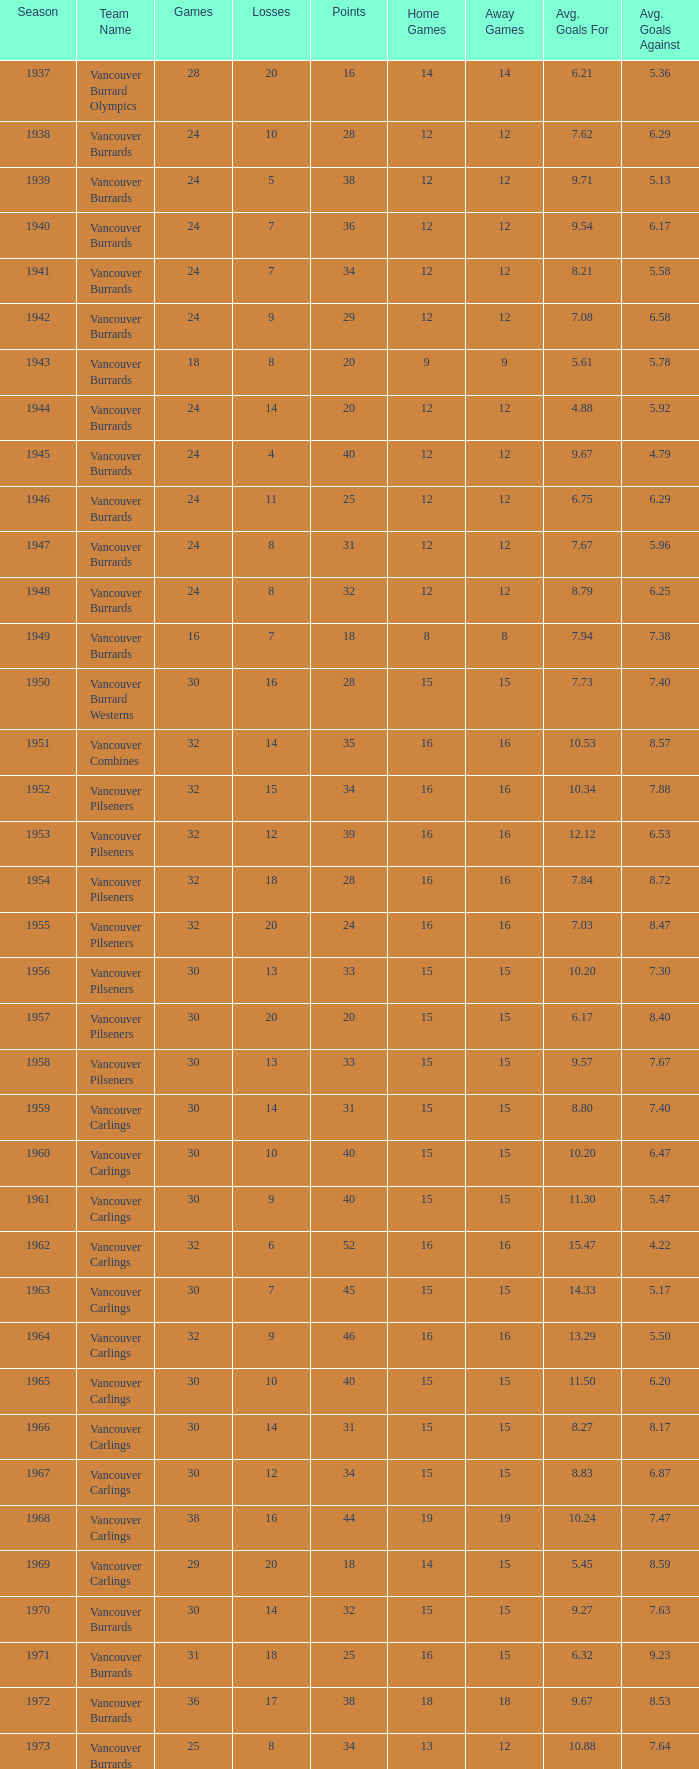What's the sum of points for the 1963 season when there are more than 30 games? None. Could you parse the entire table as a dict? {'header': ['Season', 'Team Name', 'Games', 'Losses', 'Points', 'Home Games', 'Away Games', 'Avg. Goals For', 'Avg. Goals Against'], 'rows': [['1937', 'Vancouver Burrard Olympics', '28', '20', '16', '14', '14', '6.21', '5.36'], ['1938', 'Vancouver Burrards', '24', '10', '28', '12', '12', '7.62', '6.29'], ['1939', 'Vancouver Burrards', '24', '5', '38', '12', '12', '9.71', '5.13'], ['1940', 'Vancouver Burrards', '24', '7', '36', '12', '12', '9.54', '6.17'], ['1941', 'Vancouver Burrards', '24', '7', '34', '12', '12', '8.21', '5.58'], ['1942', 'Vancouver Burrards', '24', '9', '29', '12', '12', '7.08', '6.58'], ['1943', 'Vancouver Burrards', '18', '8', '20', '9', '9', '5.61', '5.78'], ['1944', 'Vancouver Burrards', '24', '14', '20', '12', '12', '4.88', '5.92'], ['1945', 'Vancouver Burrards', '24', '4', '40', '12', '12', '9.67', '4.79'], ['1946', 'Vancouver Burrards', '24', '11', '25', '12', '12', '6.75', '6.29'], ['1947', 'Vancouver Burrards', '24', '8', '31', '12', '12', '7.67', '5.96'], ['1948', 'Vancouver Burrards', '24', '8', '32', '12', '12', '8.79', '6.25'], ['1949', 'Vancouver Burrards', '16', '7', '18', '8', '8', '7.94', '7.38'], ['1950', 'Vancouver Burrard Westerns', '30', '16', '28', '15', '15', '7.73', '7.40'], ['1951', 'Vancouver Combines', '32', '14', '35', '16', '16', '10.53', '8.57'], ['1952', 'Vancouver Pilseners', '32', '15', '34', '16', '16', '10.34', '7.88'], ['1953', 'Vancouver Pilseners', '32', '12', '39', '16', '16', '12.12', '6.53'], ['1954', 'Vancouver Pilseners', '32', '18', '28', '16', '16', '7.84', '8.72'], ['1955', 'Vancouver Pilseners', '32', '20', '24', '16', '16', '7.03', '8.47'], ['1956', 'Vancouver Pilseners', '30', '13', '33', '15', '15', '10.20', '7.30'], ['1957', 'Vancouver Pilseners', '30', '20', '20', '15', '15', '6.17', '8.40'], ['1958', 'Vancouver Pilseners', '30', '13', '33', '15', '15', '9.57', '7.67'], ['1959', 'Vancouver Carlings', '30', '14', '31', '15', '15', '8.80', '7.40'], ['1960', 'Vancouver Carlings', '30', '10', '40', '15', '15', '10.20', '6.47'], ['1961', 'Vancouver Carlings', '30', '9', '40', '15', '15', '11.30', '5.47'], ['1962', 'Vancouver Carlings', '32', '6', '52', '16', '16', '15.47', '4.22'], ['1963', 'Vancouver Carlings', '30', '7', '45', '15', '15', '14.33', '5.17'], ['1964', 'Vancouver Carlings', '32', '9', '46', '16', '16', '13.29', '5.50'], ['1965', 'Vancouver Carlings', '30', '10', '40', '15', '15', '11.50', '6.20'], ['1966', 'Vancouver Carlings', '30', '14', '31', '15', '15', '8.27', '8.17'], ['1967', 'Vancouver Carlings', '30', '12', '34', '15', '15', '8.83', '6.87'], ['1968', 'Vancouver Carlings', '38', '16', '44', '19', '19', '10.24', '7.47'], ['1969', 'Vancouver Carlings', '29', '20', '18', '14', '15', '5.45', '8.59'], ['1970', 'Vancouver Burrards', '30', '14', '32', '15', '15', '9.27', '7.63'], ['1971', 'Vancouver Burrards', '31', '18', '25', '16', '15', '6.32', '9.23'], ['1972', 'Vancouver Burrards', '36', '17', '38', '18', '18', '9.67', '8.53'], ['1973', 'Vancouver Burrards', '25', '8', '34', '13', '12', '10.88', '7.64'], ['1974', 'Vancouver Burrards', '24', '13', '22', '12', '12', '8.61', '8.71'], ['1975', 'Vancouver Burrards', '24', '10', '28', '12', '12', '9.33', '7.17'], ['1976', 'Vancouver Burrards', '24', '14', '20', '12', '12', '6.58', '10.04'], ['1977', 'Vancouver Burrards', '24', '7', '33', '12', '12', '10.25', '6.75'], ['1978', 'Vancouver Burrards', '24', '13', '22', '12', '12', '8.25', '8.25'], ['1979', 'Vancouver Burrards', '30', '19', '22', '15', '15', '7.60', '9.50'], ['1980', 'Vancouver Burrards', '24', '13', '22', '12', '12', '8.08', '8.92'], ['1981', 'Vancouver Burrards', '24', '12', '24', '12', '12', '7.63', '7.58'], ['1982', 'Vancouver Burrards', '24', '12', '24', '12', '12', '8.42', '7.79'], ['1983', 'Vancouver Burrards', '24', '10', '28', '12', '12', '8.21', '7.50'], ['1984', 'Vancouver Burrards', '24', '15', '18', '12', '12', '6.50', '8.50'], ['1985', 'Vancouver Burrards', '24', '13', '22', '12', '12', '7.79', '7.58'], ['1986', 'Vancouver Burrards', '24', '11', '26', '12', '12', '9.50', '7.08'], ['1987', 'Vancouver Burrards', '24', '14', '20', '12', '12', '6.83', '8.50'], ['1988', 'Vancouver Burrards', '24', '13', '22', '12', '12', '7.38', '8.21'], ['1989', 'Vancouver Burrards', '24', '15', '18', '12', '12', '7.96', '7.38'], ['1990', 'Vancouver Burrards', '24', '8', '32', '12', '12', '10.29', '6.08'], ['1991', 'Vancouver Burrards', '24', '16', '16', '12', '12', '6.54', '8.67'], ['1992', 'Vancouver Burrards', '24', '15', '18', '12', '12', '8.13', '8.25'], ['1993', 'Vancouver Burrards', '24', '20', '8', '12', '12', '7.63', '9.04'], ['1994', 'Surrey Burrards', '20', '12', '16', '10', '10', '6.10', '9.05'], ['1995', 'Surrey Burrards', '25', '19', '11', '12', '13', '6.04', '10.12'], ['1996', 'Maple Ridge Burrards', '20', '8', '23', '10', '10', '11.80', '7.90'], ['1997', 'Maple Ridge Burrards', '20', '8', '23', '10', '10', '9.70', '9.50'], ['1998', 'Maple Ridge Burrards', '25', '8', '32', '12', '13', '11.04', '7.72'], ['1999', 'Maple Ridge Burrards', '25', '15', '20', '12', '13', '9.16', '10.80'], ['2000', 'Maple Ridge Burrards', '25', '16', '18', '12', '13', '8.80', '10.12'], ['2001', 'Maple Ridge Burrards', '20', '16', '8', '10', '10', '8.30', '11.45'], ['2002', 'Maple Ridge Burrards', '20', '15', '8', '10', '10', '9.95', '10.10'], ['2003', 'Maple Ridge Burrards', '20', '15', '10', '10', '10', '7.76', '10.50'], ['2004', 'Maple Ridge Burrards', '20', '12', '16', '10', '10', '10.45', '8.60'], ['2005', 'Maple Ridge Burrards', '18', '8', '19', '9', '9', '10.06', '8.72'], ['2006', 'Maple Ridge Burrards', '18', '11', '14', '9', '9', '8.39', '8.72'], ['2007', 'Maple Ridge Burrards', '18', '11', '14', '9', '9', '10.72', '9.05'], ['2008', 'Maple Ridge Burrards', '18', '13', '10', '9', '9', '7.61', '8.28'], ['2009', 'Maple Ridge Burrards', '18', '11', '14', '9', '9', '9.94', '9.00'], ['2010', 'Maple Ridge Burrards', '18', '9', '18', '9', '9', '9.33', '8.78'], ['Total', '74 seasons', '1,879', '913', '1,916', '-', '-', '8.48', '7.10']]} 